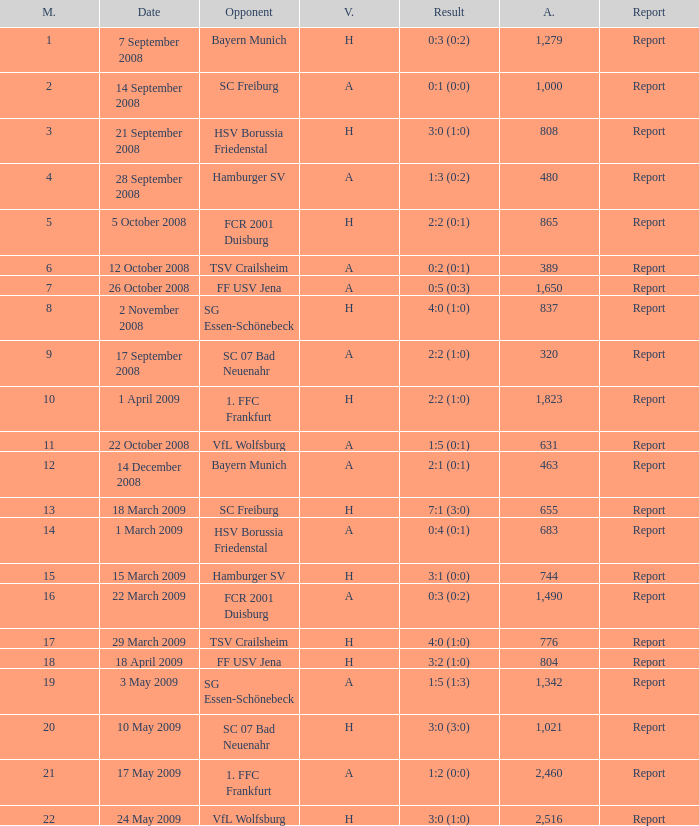Which match had more than 1,490 people in attendance to watch FCR 2001 Duisburg have a result of 0:3 (0:2)? None. 